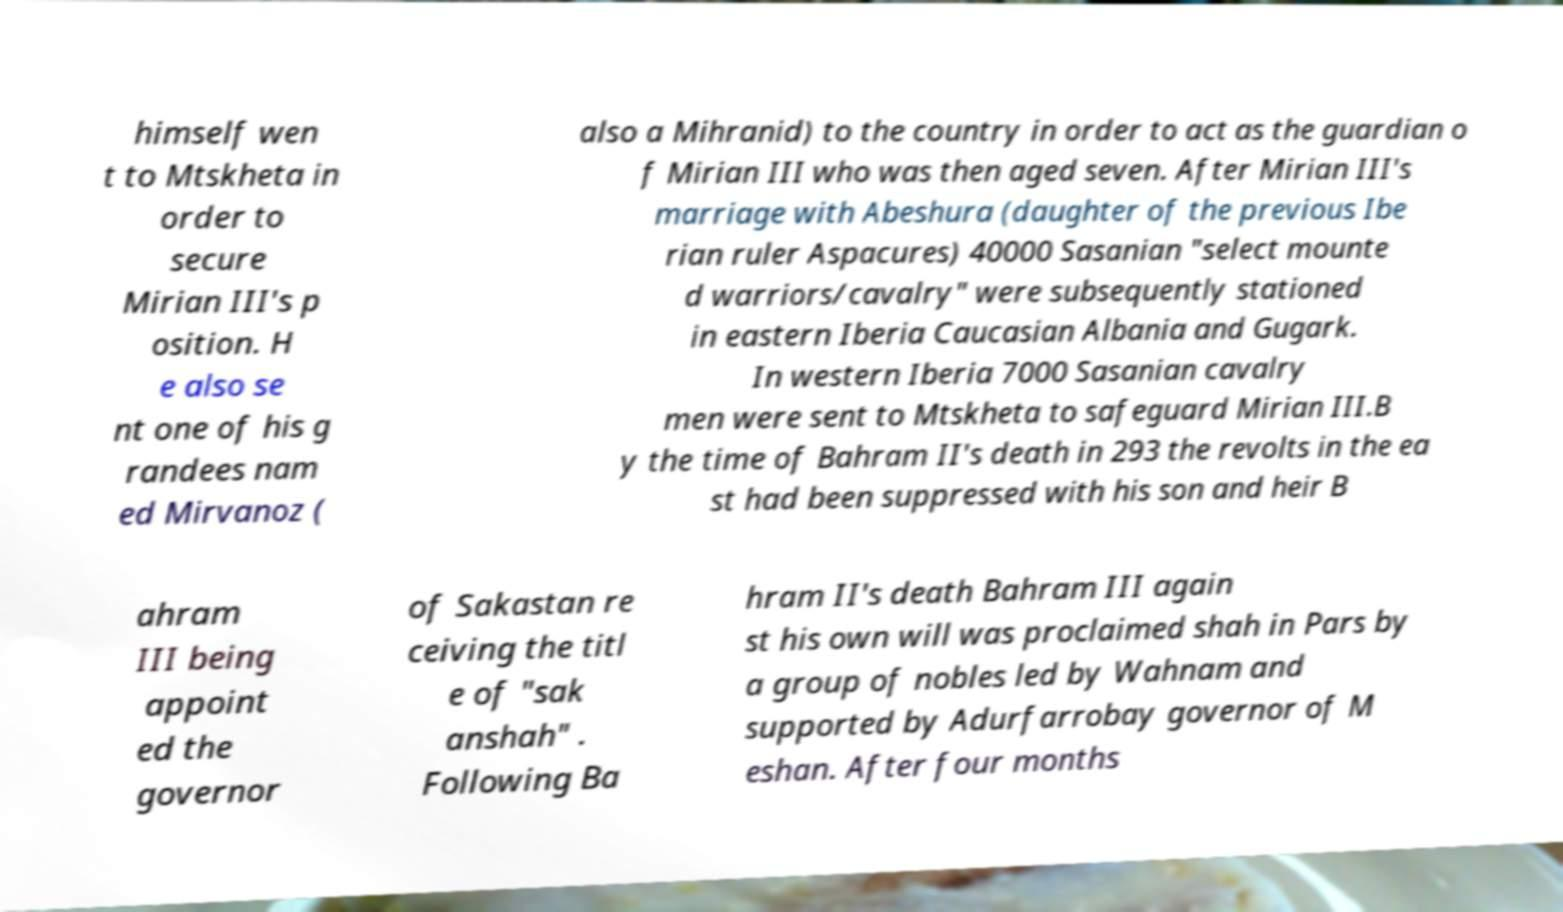There's text embedded in this image that I need extracted. Can you transcribe it verbatim? himself wen t to Mtskheta in order to secure Mirian III's p osition. H e also se nt one of his g randees nam ed Mirvanoz ( also a Mihranid) to the country in order to act as the guardian o f Mirian III who was then aged seven. After Mirian III's marriage with Abeshura (daughter of the previous Ibe rian ruler Aspacures) 40000 Sasanian "select mounte d warriors/cavalry" were subsequently stationed in eastern Iberia Caucasian Albania and Gugark. In western Iberia 7000 Sasanian cavalry men were sent to Mtskheta to safeguard Mirian III.B y the time of Bahram II's death in 293 the revolts in the ea st had been suppressed with his son and heir B ahram III being appoint ed the governor of Sakastan re ceiving the titl e of "sak anshah" . Following Ba hram II's death Bahram III again st his own will was proclaimed shah in Pars by a group of nobles led by Wahnam and supported by Adurfarrobay governor of M eshan. After four months 